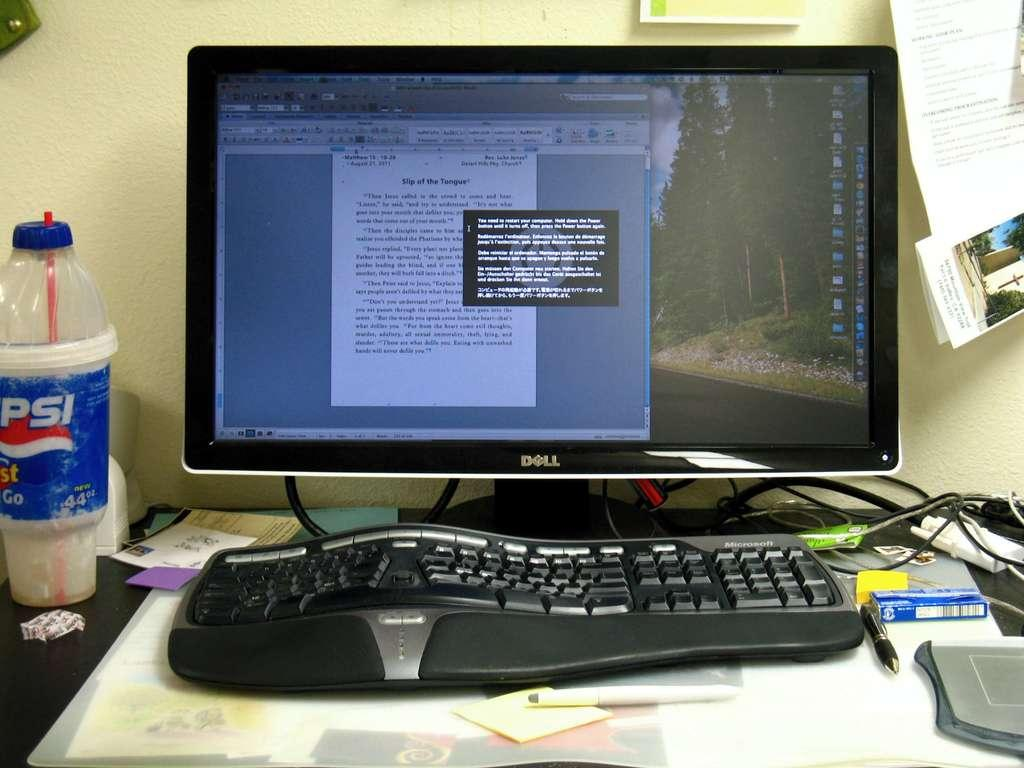Provide a one-sentence caption for the provided image. a computer with a document that says slip of the tongue. 